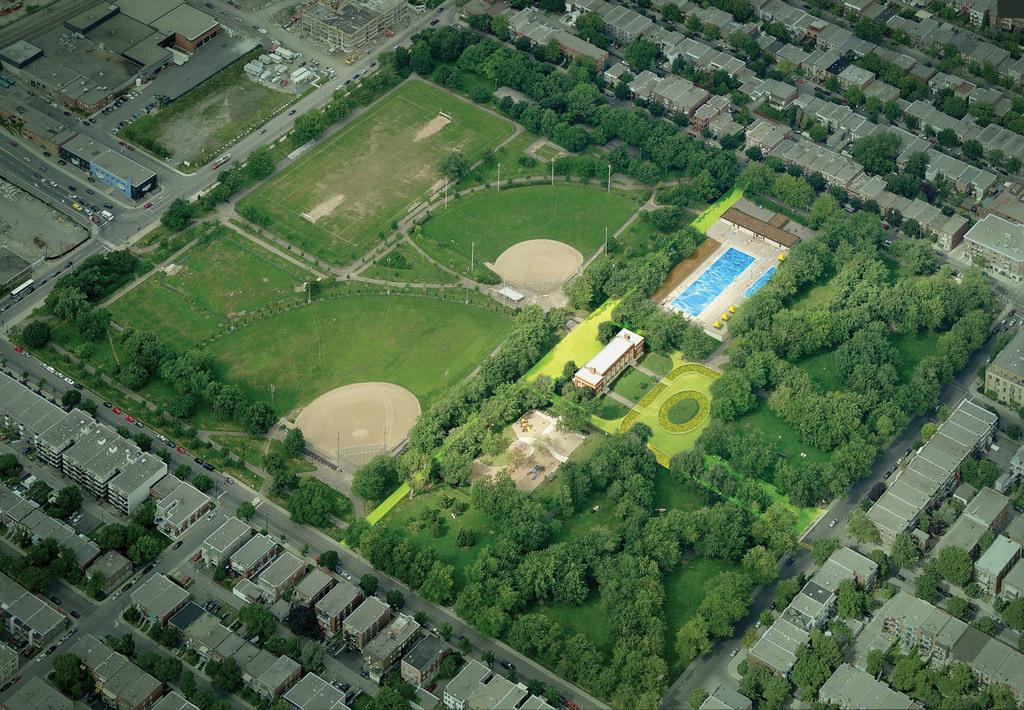What type of structures can be seen in the image? There are buildings in the image. What type of vegetation is present in the image? There are trees, grass, and plants in the image. What are the poles used for in the image? The purpose of the poles in the image is not specified, but they could be for various purposes such as lighting or signage. What type of objects can be seen moving in the image? There are vehicles in the image, which suggests that they are moving. What type of scarf is draped over the basin in the image? There is no scarf or basin present in the image. In which direction are the buildings facing in the image? The direction in which the buildings are facing cannot be determined from the image. 